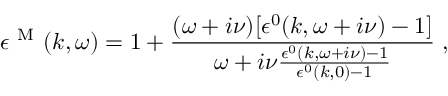Convert formula to latex. <formula><loc_0><loc_0><loc_500><loc_500>\epsilon ^ { M } ( k , \omega ) = 1 + \frac { ( \omega + i \nu ) [ \epsilon ^ { 0 } ( k , \omega + i \nu ) - 1 ] } { \omega + i \nu \frac { \epsilon ^ { 0 } ( k , \omega + i \nu ) - 1 } { \epsilon ^ { 0 } ( k , 0 ) - 1 } } \, ,</formula> 